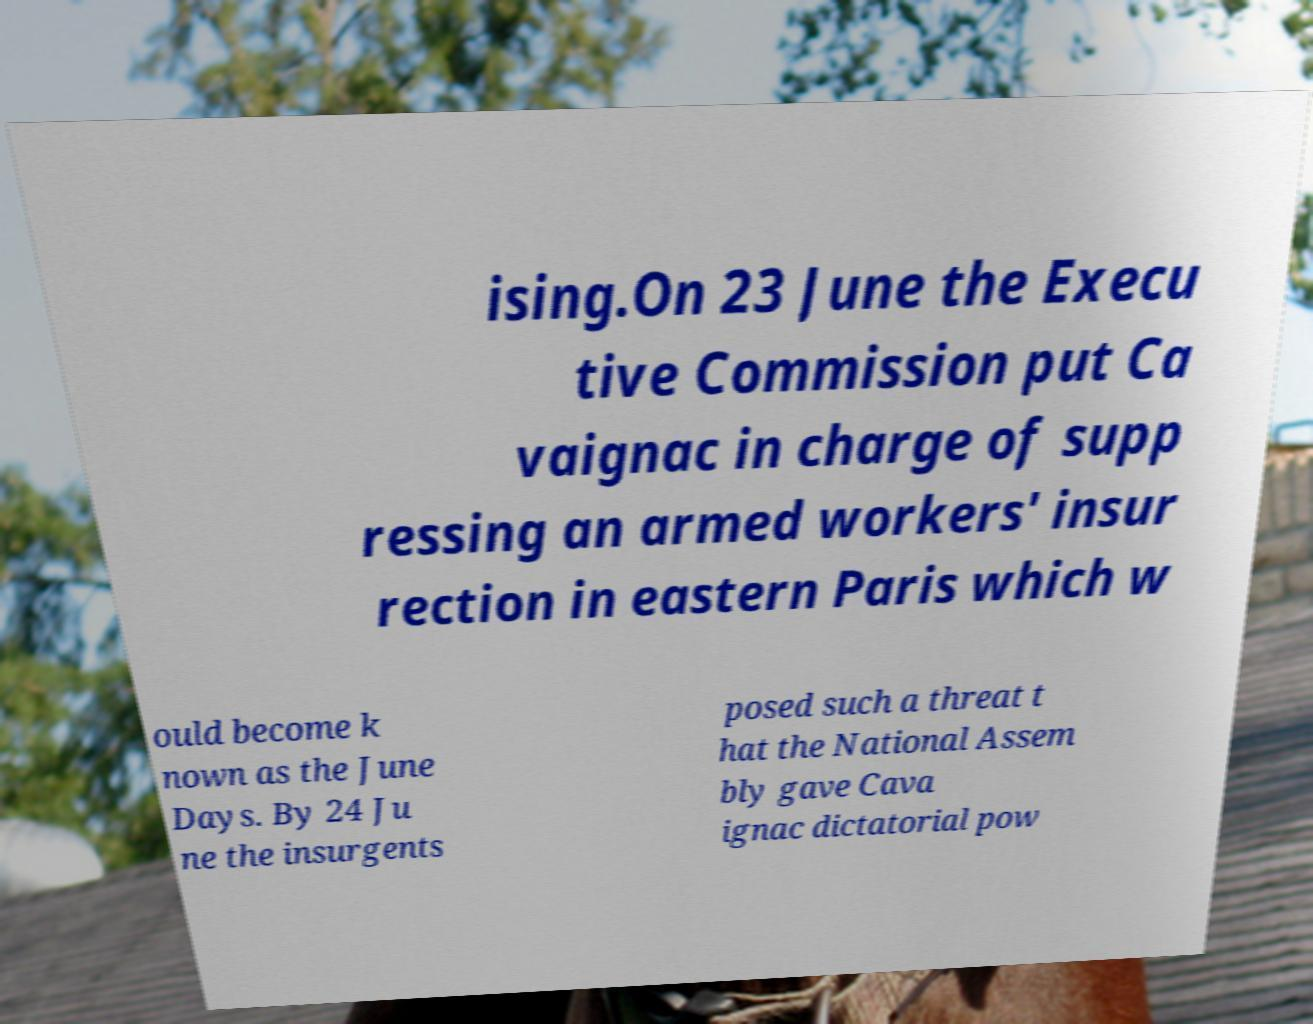Can you accurately transcribe the text from the provided image for me? ising.On 23 June the Execu tive Commission put Ca vaignac in charge of supp ressing an armed workers' insur rection in eastern Paris which w ould become k nown as the June Days. By 24 Ju ne the insurgents posed such a threat t hat the National Assem bly gave Cava ignac dictatorial pow 